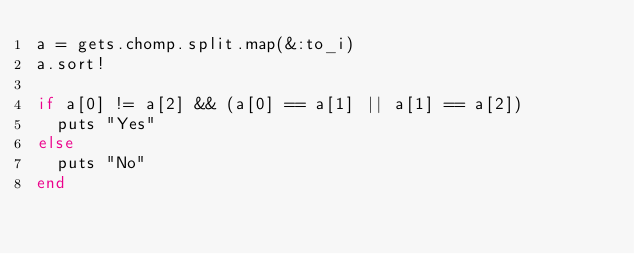<code> <loc_0><loc_0><loc_500><loc_500><_Ruby_>a = gets.chomp.split.map(&:to_i)
a.sort!

if a[0] != a[2] && (a[0] == a[1] || a[1] == a[2])
  puts "Yes"
else
  puts "No"
end</code> 